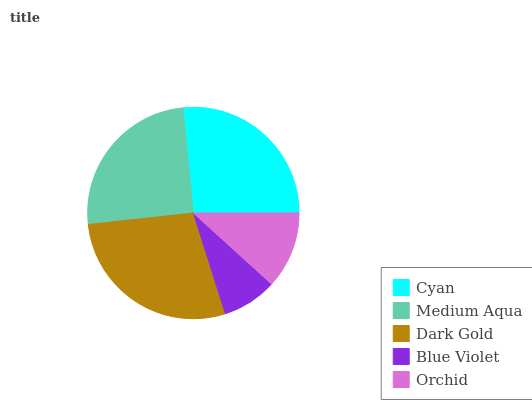Is Blue Violet the minimum?
Answer yes or no. Yes. Is Dark Gold the maximum?
Answer yes or no. Yes. Is Medium Aqua the minimum?
Answer yes or no. No. Is Medium Aqua the maximum?
Answer yes or no. No. Is Cyan greater than Medium Aqua?
Answer yes or no. Yes. Is Medium Aqua less than Cyan?
Answer yes or no. Yes. Is Medium Aqua greater than Cyan?
Answer yes or no. No. Is Cyan less than Medium Aqua?
Answer yes or no. No. Is Medium Aqua the high median?
Answer yes or no. Yes. Is Medium Aqua the low median?
Answer yes or no. Yes. Is Cyan the high median?
Answer yes or no. No. Is Blue Violet the low median?
Answer yes or no. No. 